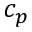Convert formula to latex. <formula><loc_0><loc_0><loc_500><loc_500>c _ { p }</formula> 